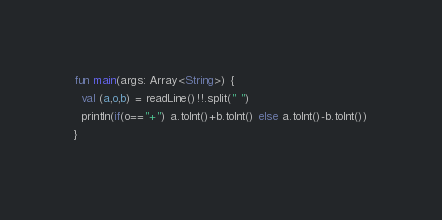Convert code to text. <code><loc_0><loc_0><loc_500><loc_500><_Kotlin_>fun main(args: Array<String>) {
  val (a,o,b) = readLine()!!.split(" ")
  println(if(o=="+") a.toInt()+b.toInt() else a.toInt()-b.toInt())
}</code> 